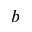Convert formula to latex. <formula><loc_0><loc_0><loc_500><loc_500>b</formula> 